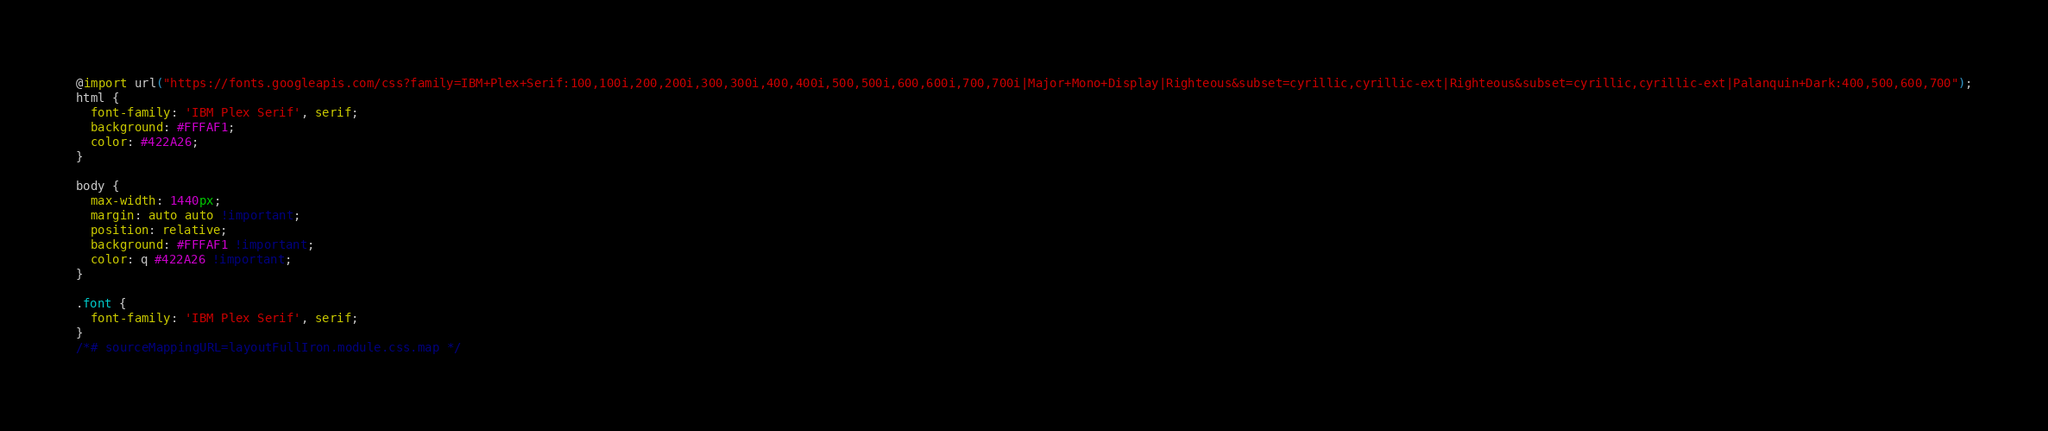Convert code to text. <code><loc_0><loc_0><loc_500><loc_500><_CSS_>@import url("https://fonts.googleapis.com/css?family=IBM+Plex+Serif:100,100i,200,200i,300,300i,400,400i,500,500i,600,600i,700,700i|Major+Mono+Display|Righteous&subset=cyrillic,cyrillic-ext|Righteous&subset=cyrillic,cyrillic-ext|Palanquin+Dark:400,500,600,700");
html {
  font-family: 'IBM Plex Serif', serif;
  background: #FFFAF1;
  color: #422A26;
}

body {
  max-width: 1440px;
  margin: auto auto !important;
  position: relative;
  background: #FFFAF1 !important;
  color: q #422A26 !important;
}

.font {
  font-family: 'IBM Plex Serif', serif;
}
/*# sourceMappingURL=layoutFullIron.module.css.map */</code> 